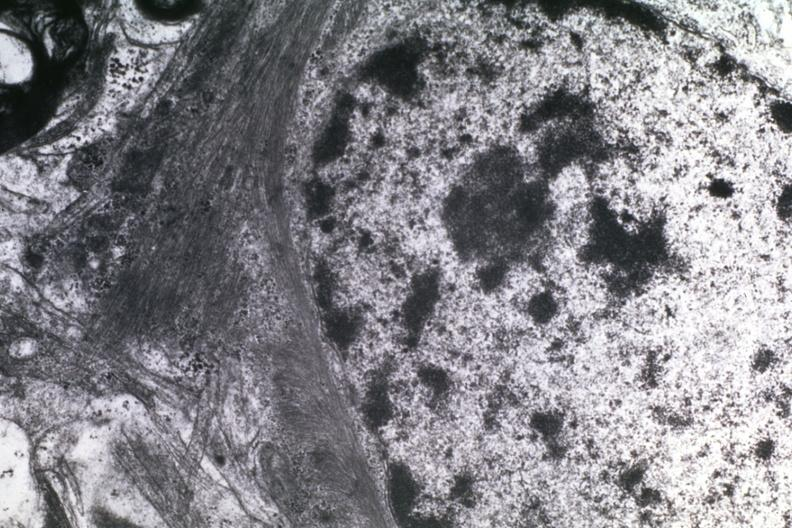s bone marrow present?
Answer the question using a single word or phrase. No 